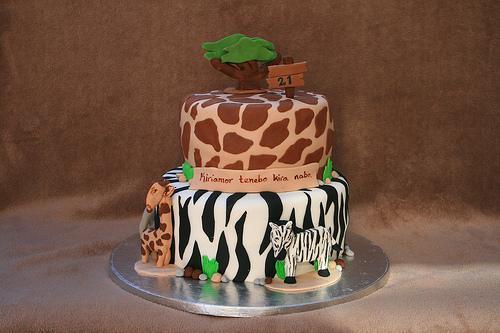How many animals in photo?
Give a very brief answer. 2. 